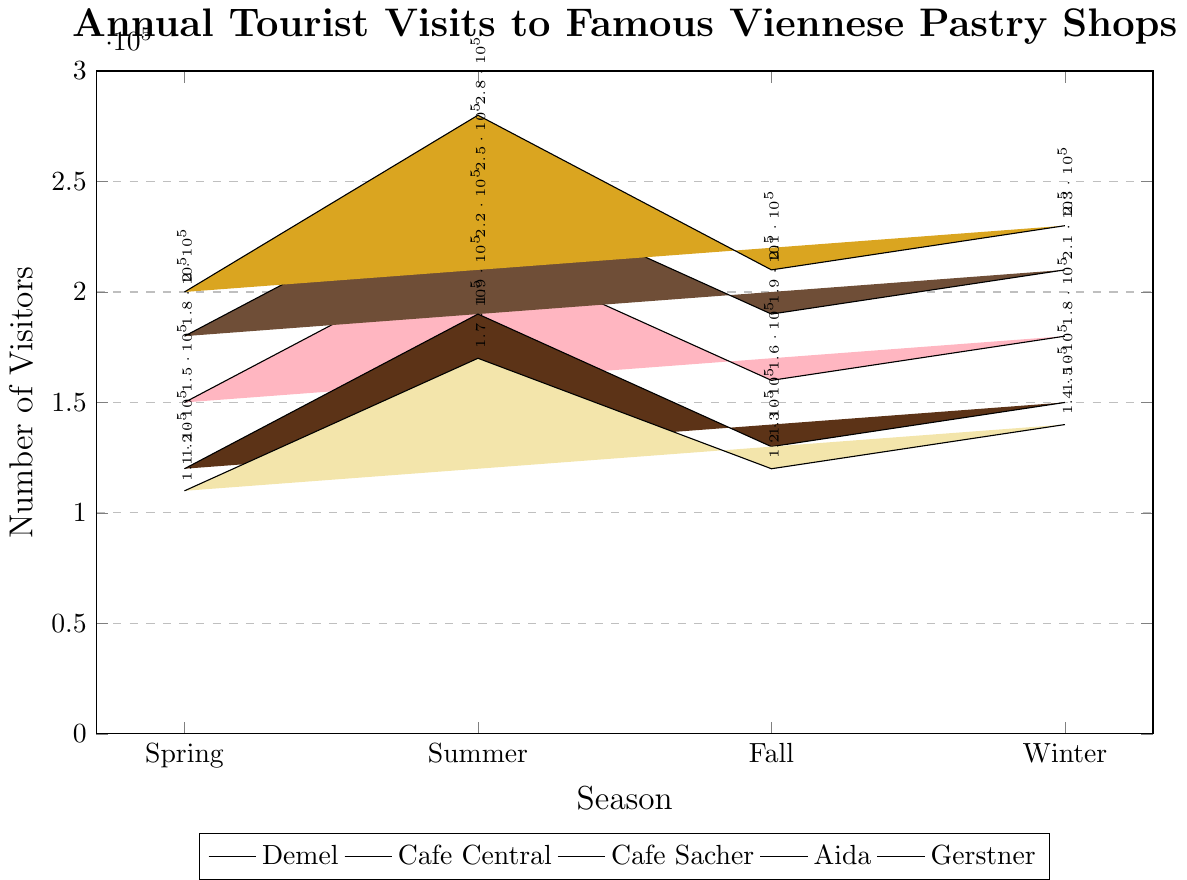What's the total number of tourist visits to Cafe Sacher in all seasons? Sum the number of visits to Cafe Sacher for each season: 200,000 + 280,000 + 210,000 + 230,000. Thus, the total number of visits is 920,000.
Answer: 920,000 Which pastry shop had the fewest visitors in Winter? Compare the number of visitors in Winter for all pastry shops: Demel (180,000), Cafe Central (210,000), Cafe Sacher (230,000), Aida (150,000), Gerstner (140,000). Gerstner had the fewest visitors.
Answer: Gerstner In which season did Cafe Central have the highest number of visitors? Compare the number of visitors to Cafe Central in all seasons: Spring (180,000), Summer (250,000), Fall (190,000), Winter (210,000). The highest number was in Summer.
Answer: Summer What is the difference in tourist visits between Spring and Fall for Aida? Subtract the number of visits in Fall from those in Spring for Aida: 120,000 - 130,000. The difference is -10,000.
Answer: -10,000 Which shop had a higher number of visitors in Spring, Demel or Cafe Central? Compare the number of visitors in Spring: Demel (150,000) and Cafe Central (180,000). Cafe Central had more visitors.
Answer: Cafe Central What is the average number of tourist visits per season for Gerstner? Sum the number of visits for each season, then divide by the number of seasons: (110,000 + 170,000 + 120,000 + 140,000) / 4. Thus, the average is 135,000.
Answer: 135,000 Which two shops had a difference of 50,000 visitors in Summer? Calculate the difference in visits between each pair of shops for Summer: Demel (220,000), Cafe Central (250,000), Cafe Sacher (280,000), Aida (190,000), Gerstner (170,000). Demel vs Aida is 30,000, Demel vs Cafe Central is 30,000, Demel vs Cafe Sacher is 60,000, Demel vs Gerstner is 50,000, Aida vs Gerstner is 20,000. Demel and Gerstner had a difference of 50,000 visitors.
Answer: Demel and Gerstner 